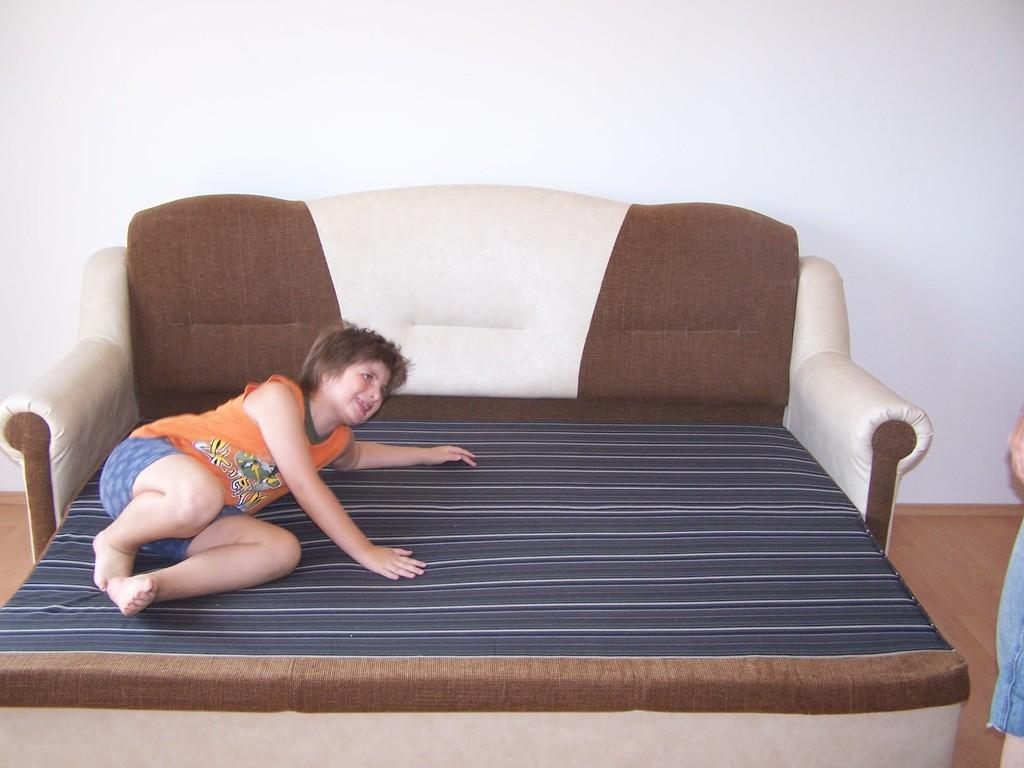What is the lady doing in the image? The lady is lying on a bed in the image. What is unique about the bed? The bed is also a sofa. What can be seen in the background of the image? There is a wall in the background. What type of paper is the lady reading on the bed? There is no paper visible in the image, and the lady is not shown reading anything. 